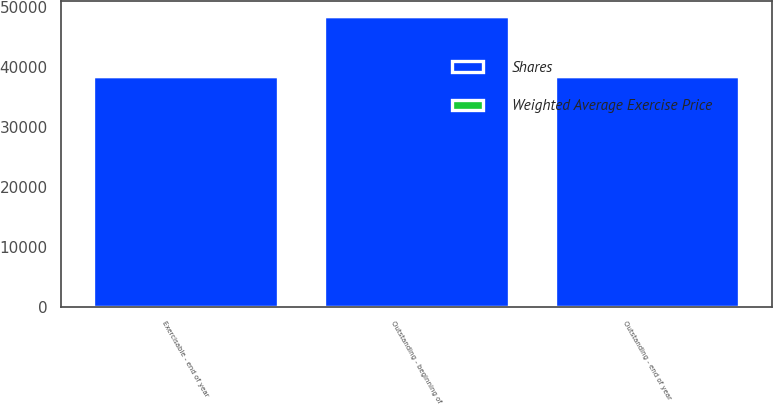Convert chart to OTSL. <chart><loc_0><loc_0><loc_500><loc_500><stacked_bar_chart><ecel><fcel>Outstanding - beginning of<fcel>Outstanding - end of year<fcel>Exercisable - end of year<nl><fcel>Shares<fcel>48446<fcel>38454<fcel>38454<nl><fcel>Weighted Average Exercise Price<fcel>41.71<fcel>44.99<fcel>44.99<nl></chart> 